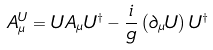Convert formula to latex. <formula><loc_0><loc_0><loc_500><loc_500>A ^ { U } _ { \mu } = U A _ { \mu } U ^ { \dagger } - \frac { i } { g } \left ( \partial _ { \mu } U \right ) U ^ { \dagger }</formula> 